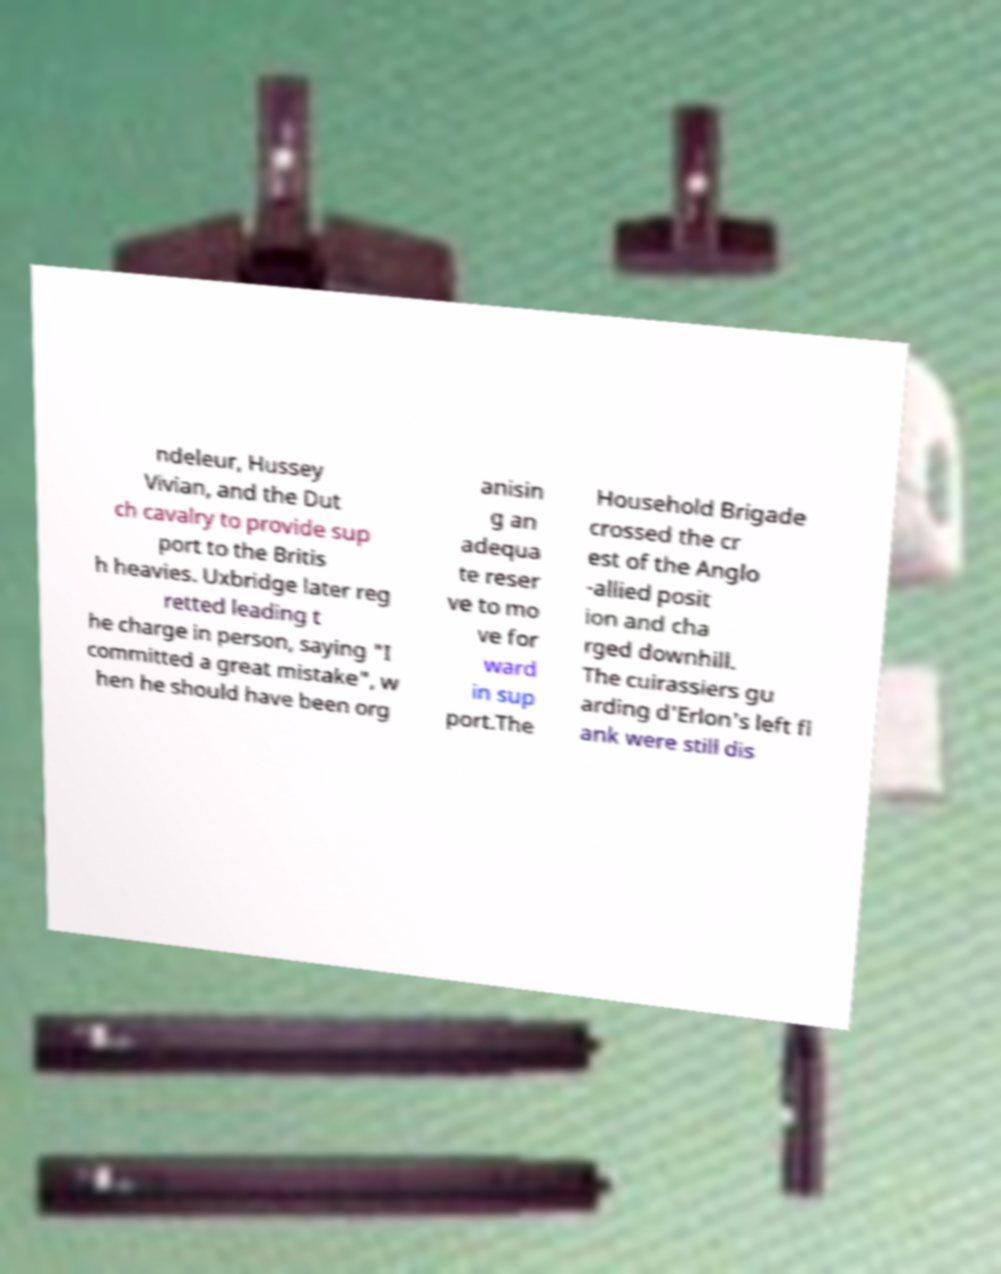Can you accurately transcribe the text from the provided image for me? ndeleur, Hussey Vivian, and the Dut ch cavalry to provide sup port to the Britis h heavies. Uxbridge later reg retted leading t he charge in person, saying "I committed a great mistake", w hen he should have been org anisin g an adequa te reser ve to mo ve for ward in sup port.The Household Brigade crossed the cr est of the Anglo -allied posit ion and cha rged downhill. The cuirassiers gu arding d'Erlon's left fl ank were still dis 